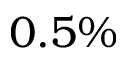<formula> <loc_0><loc_0><loc_500><loc_500>0 . 5 \%</formula> 